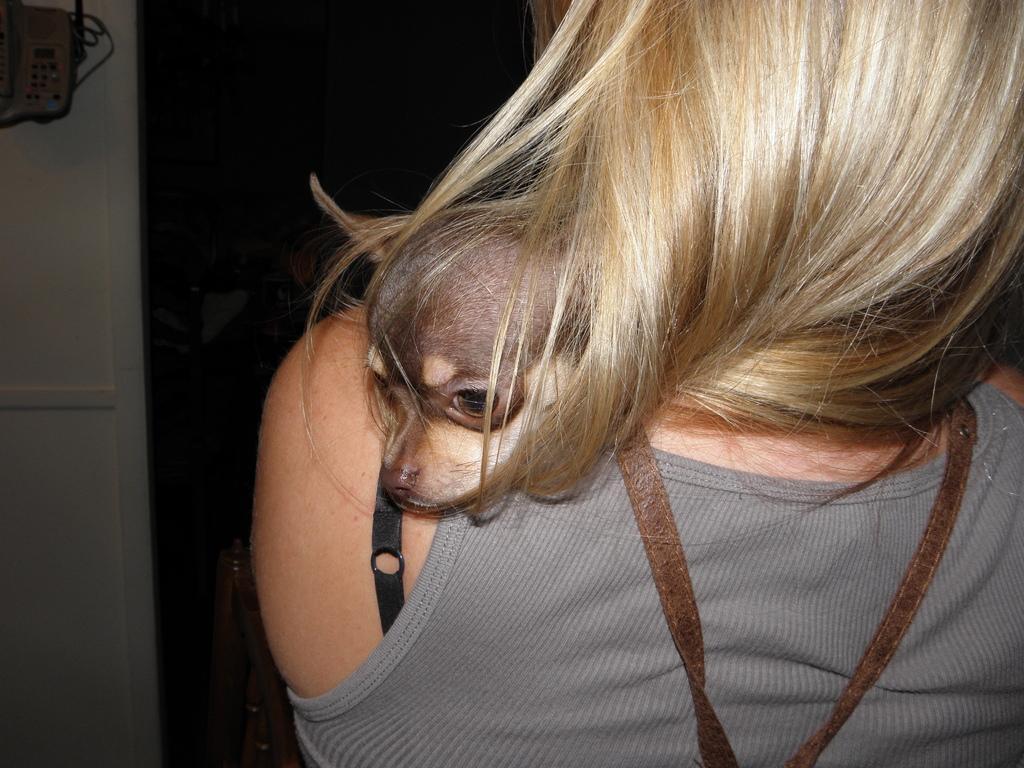Could you give a brief overview of what you see in this image? In this image we can see a person and a dog. In the background of the image there is a wall, wooden objects and other objects. 